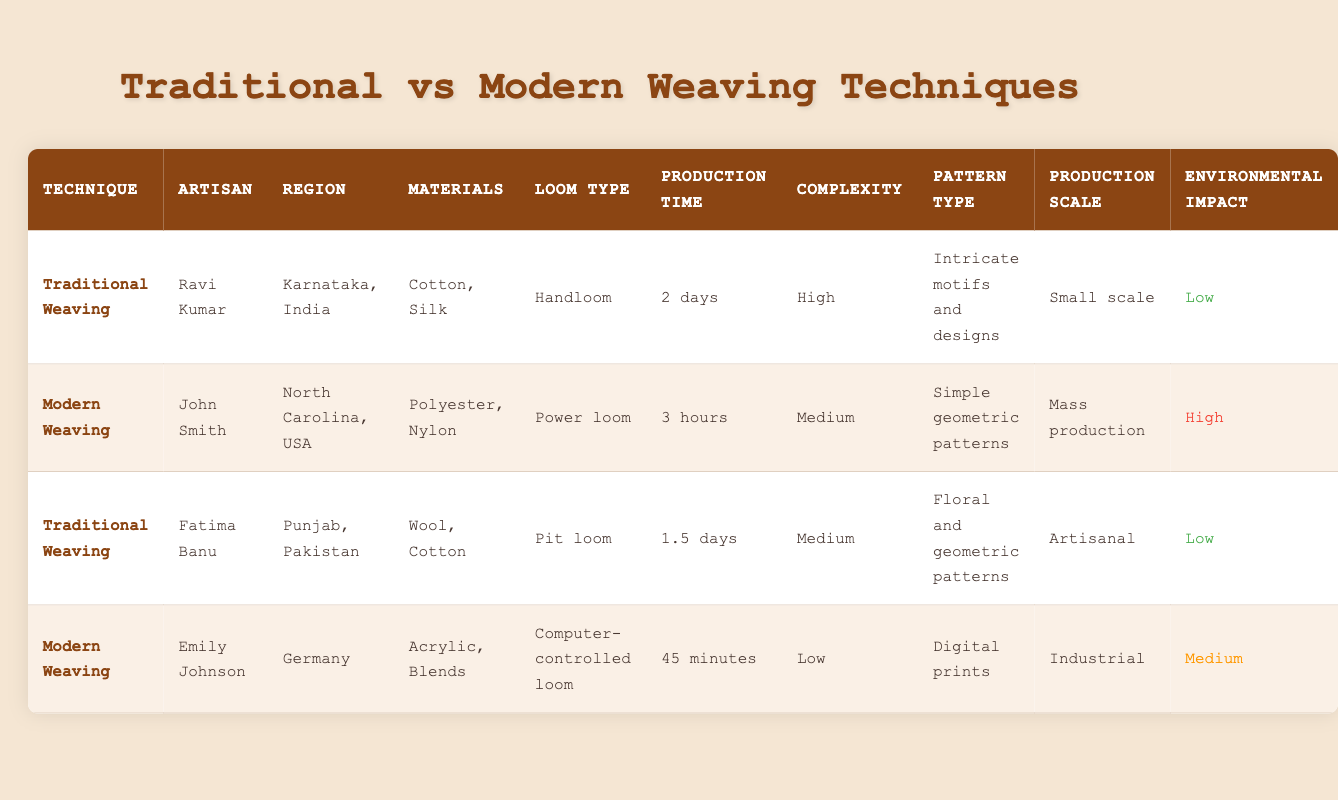What materials are used in traditional weaving by Ravi Kumar? In the table, Ravi Kumar is listed under Traditional Weaving, and the materials used are specified in the corresponding row. The materials mentioned are "Cotton, Silk."
Answer: Cotton, Silk Which technique has a lower production time per meter, Traditional or Modern Weaving? To compare production times, we see that Traditional Weaving has production times of "2 days" and "1.5 days," while Modern Weaving has "3 hours" and "45 minutes." Since 45 minutes is less than both traditional times (which convert to 48 hours maximum), Modern Weaving has lower production time.
Answer: Modern Weaving Is the environmental impact of Modern Weaving high or low? The environmental impact is listed in the table for Modern Weaving under both entries. John Smith’s entry indicates "High" impact, while Emily Johnson’s indicates "Medium." Therefore, at least one Modern Weaving entry has a high impact.
Answer: High What is the average production time per meter for Traditional Weaving? For Traditional Weaving, the production times listed are "2 days" (which is 48 hours) and "1.5 days" (which is 36 hours). The sum of these times is (48 + 36) = 84 hours. There are 2 entries, so the average is 84/2 = 42 hours.
Answer: 42 hours Which artisan uses a power loom, and what is their region? Looking at the table, we identify the use of a power loom under the Modern Weaving section. John Smith is the artisan listed with a power loom, and his region is North Carolina, USA.
Answer: John Smith, North Carolina, USA How many artisans work in Traditional Weaving as compared to Modern Weaving? From the table, there are 2 artisans under Traditional Weaving (Ravi Kumar and Fatima Banu) and 2 artisans under Modern Weaving (John Smith and Emily Johnson). Thus, "2 artisans work in both Traditional and Modern Weaving."
Answer: 2 artisans Does Fatima Banu use the same materials as Ravi Kumar? Fatima Banu uses "Wool, Cotton," and Ravi Kumar uses "Cotton, Silk." Since they do not have the same materials, the answer is NO.
Answer: No What is the complexity level associated with Traditional Weaving? The complexity levels for Traditional Weaving are listed as "High" for Ravi Kumar and "Medium" for Fatima Banu. Since it varies between high and medium, we note both levels but focus on the predominant level of "High."
Answer: High 